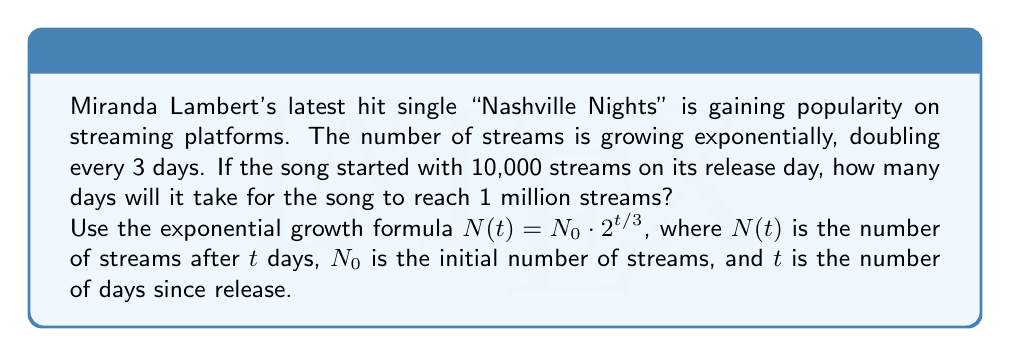Can you solve this math problem? Let's approach this step-by-step using logarithms:

1) We start with the exponential growth formula:
   $N(t) = N_0 \cdot 2^{t/3}$

2) We know:
   $N_0 = 10,000$ (initial streams)
   $N(t) = 1,000,000$ (target streams)

3) Let's substitute these values:
   $1,000,000 = 10,000 \cdot 2^{t/3}$

4) Divide both sides by 10,000:
   $100 = 2^{t/3}$

5) Now, we can use logarithms to solve for $t$. Let's use log base 2:
   $\log_2(100) = \log_2(2^{t/3})$

6) The right side simplifies due to the logarithm rule $\log_a(a^x) = x$:
   $\log_2(100) = t/3$

7) Multiply both sides by 3:
   $3 \log_2(100) = t$

8) Calculate:
   $\log_2(100) \approx 6.643856$ (using a calculator)
   $t = 3 \cdot 6.643856 \approx 19.93$ days

9) Since we can't have a fractional day in this context, we round up to the next whole day.
Answer: It will take 20 days for Miranda Lambert's "Nashville Nights" to reach 1 million streams. 